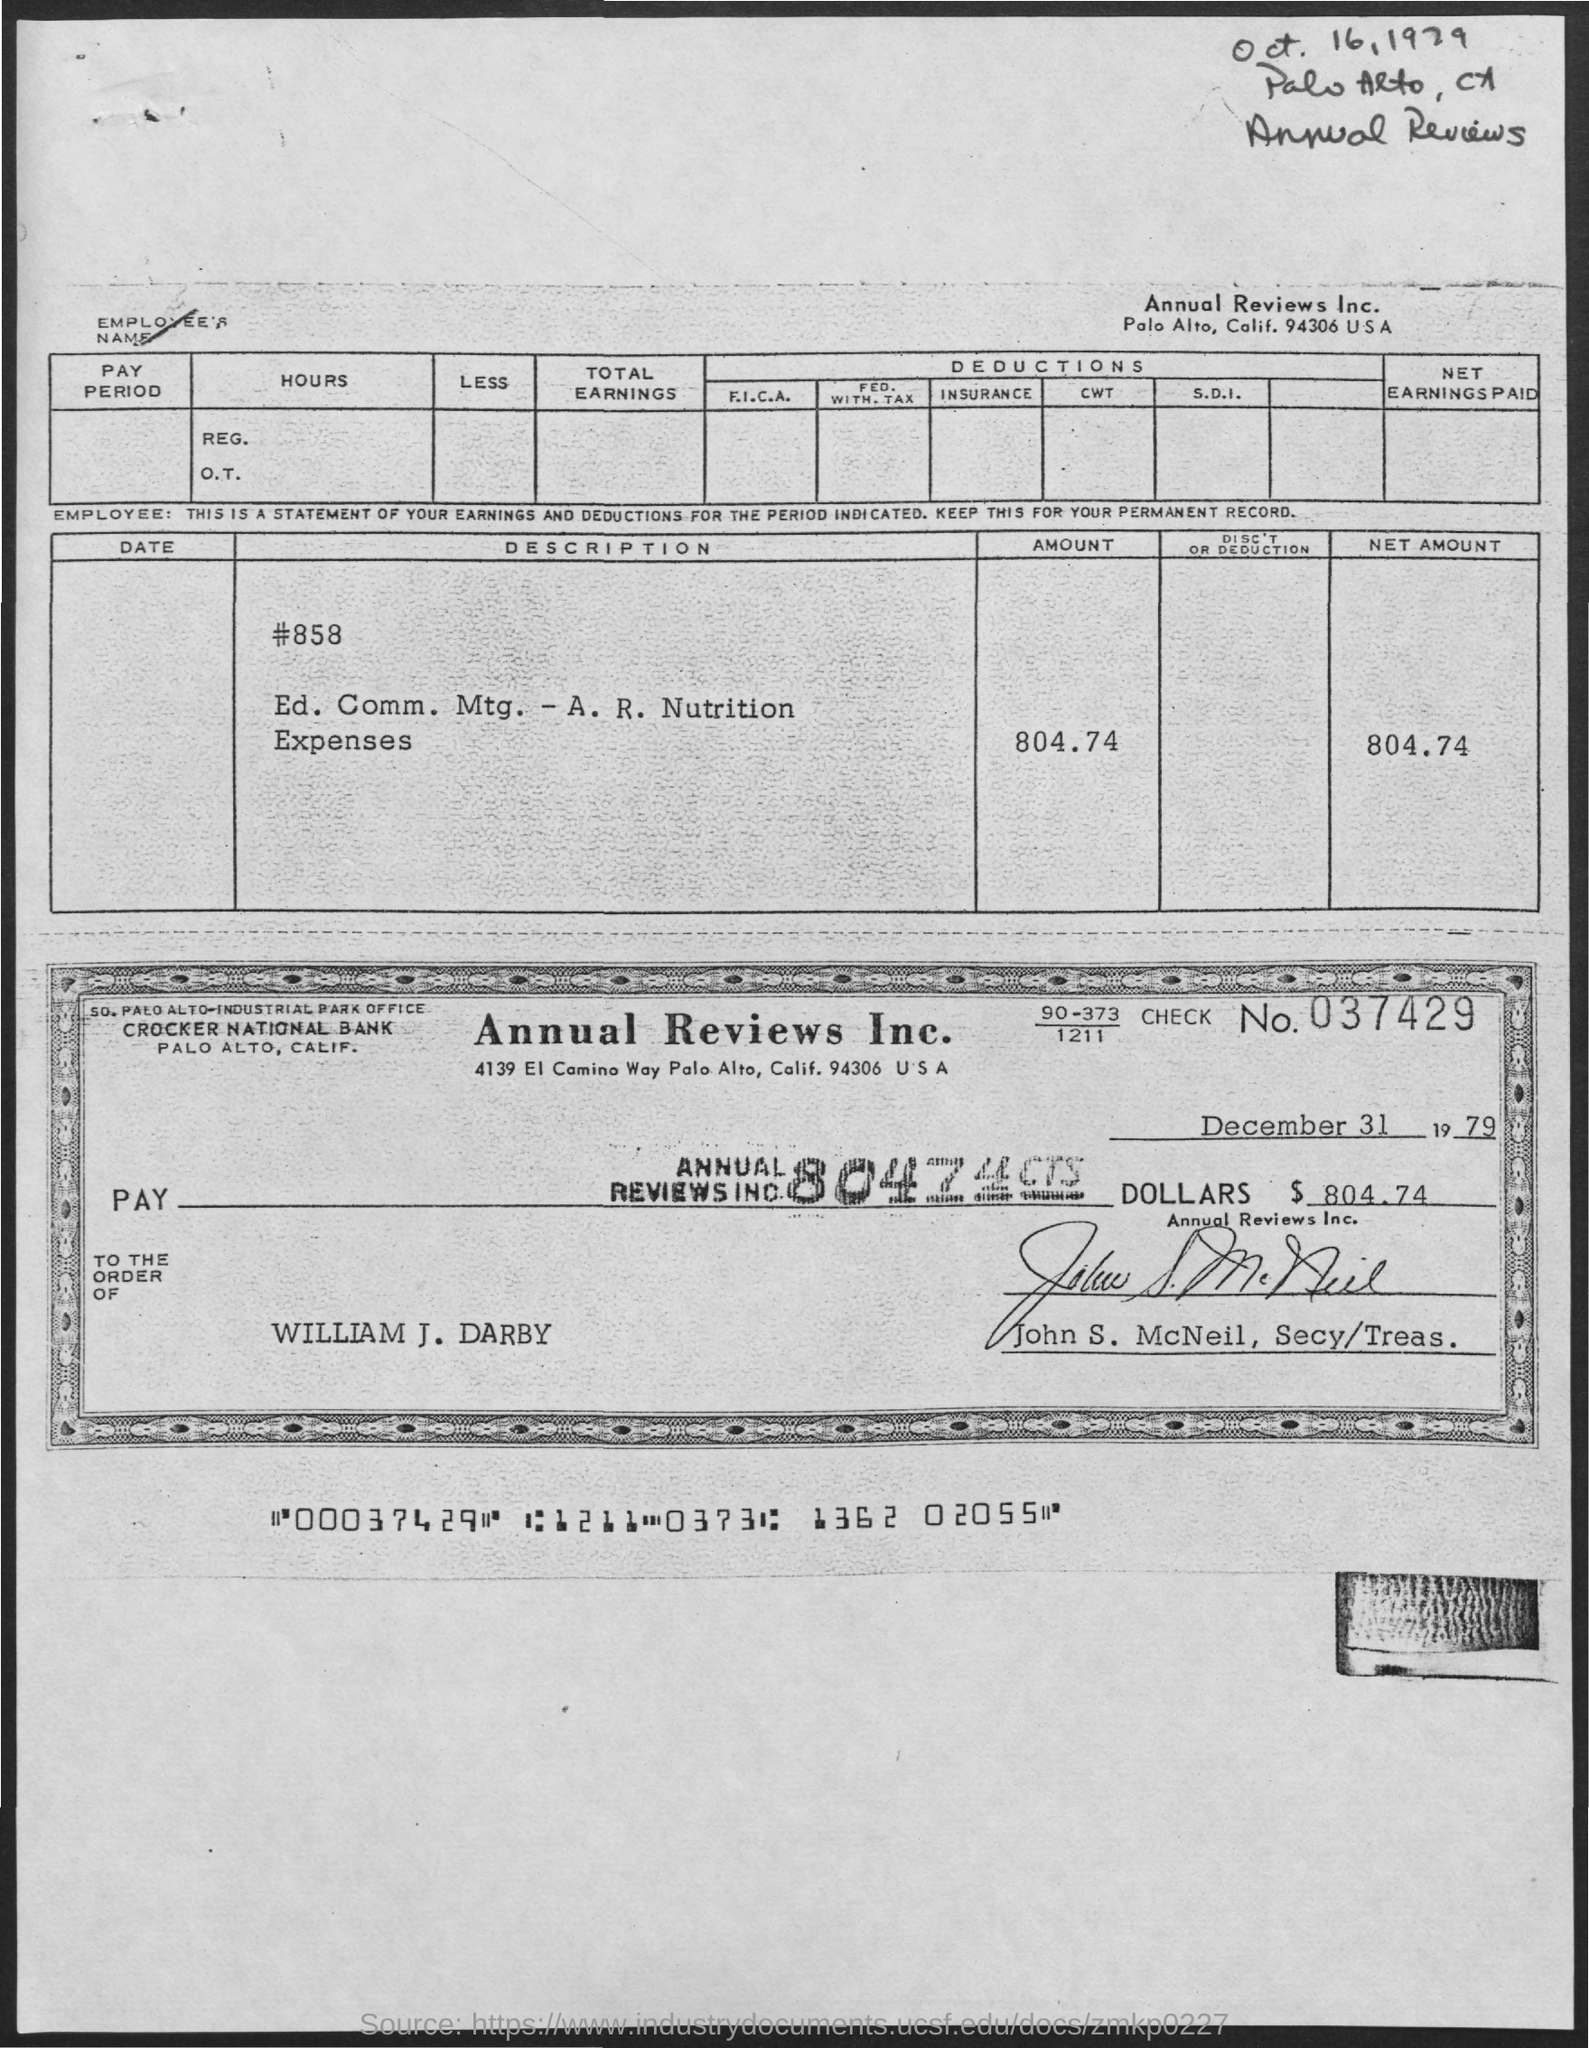List a handful of essential elements in this visual. The check is paid to the person named William J. Darby. The address of Crocker National Bank in Palo Alto, California is [object of address] . The check number is 037429. The date mentioned on the check is December 31, 1979. Annual Reviews Inc. is located in Palo Alto, California, USA, at the address of 94306. 